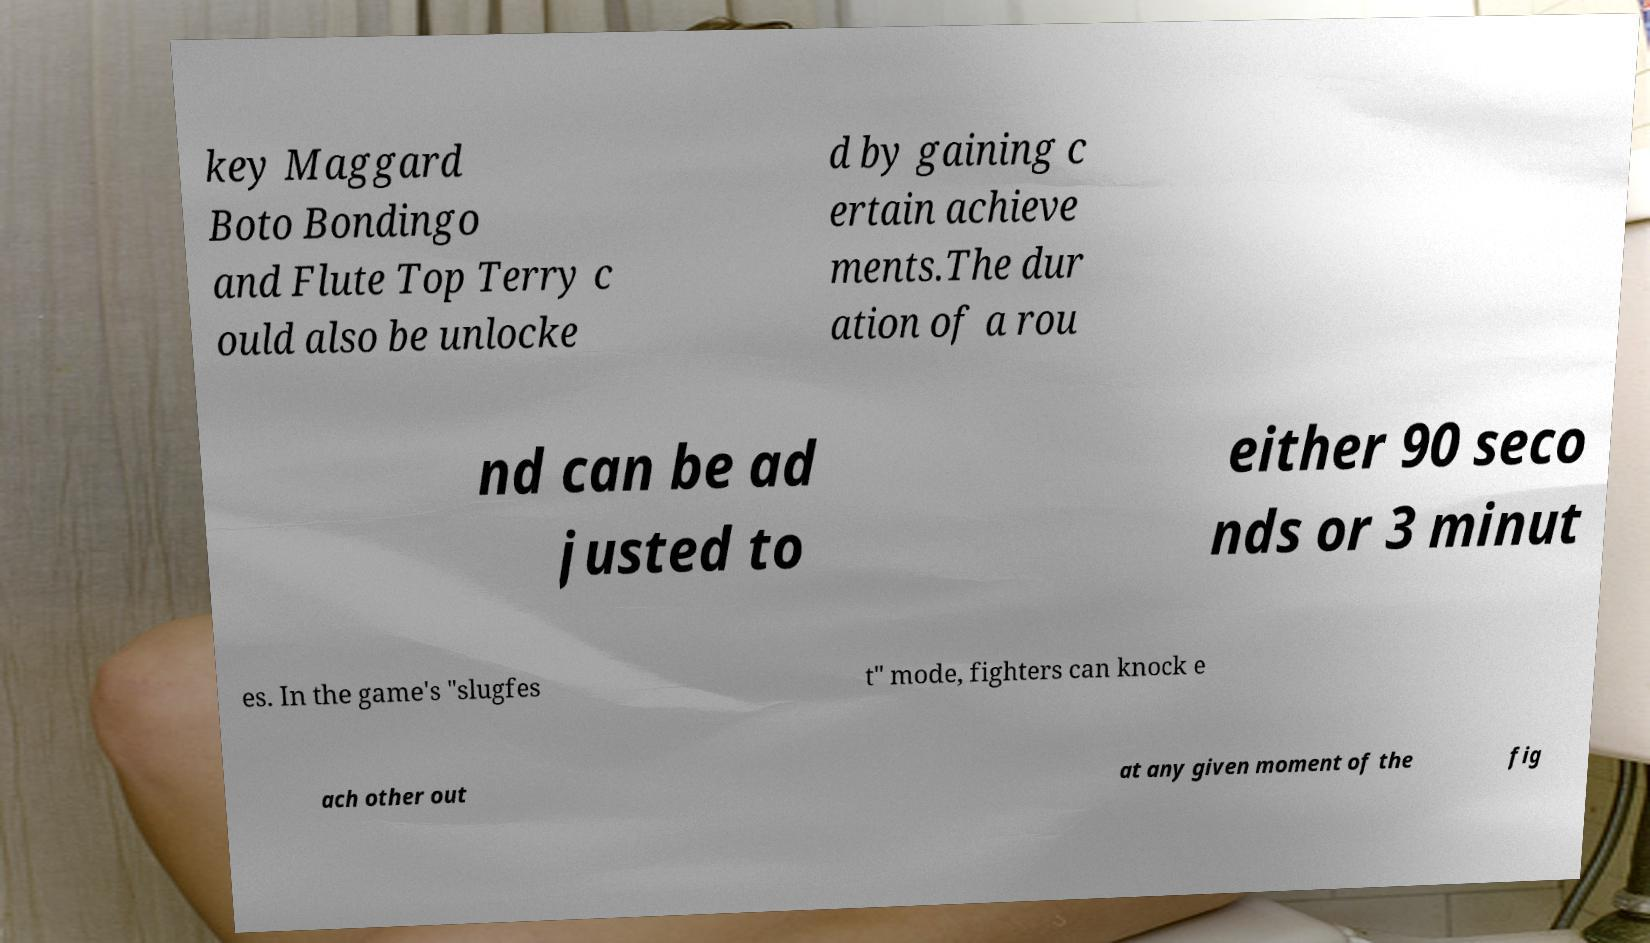There's text embedded in this image that I need extracted. Can you transcribe it verbatim? key Maggard Boto Bondingo and Flute Top Terry c ould also be unlocke d by gaining c ertain achieve ments.The dur ation of a rou nd can be ad justed to either 90 seco nds or 3 minut es. In the game's "slugfes t" mode, fighters can knock e ach other out at any given moment of the fig 